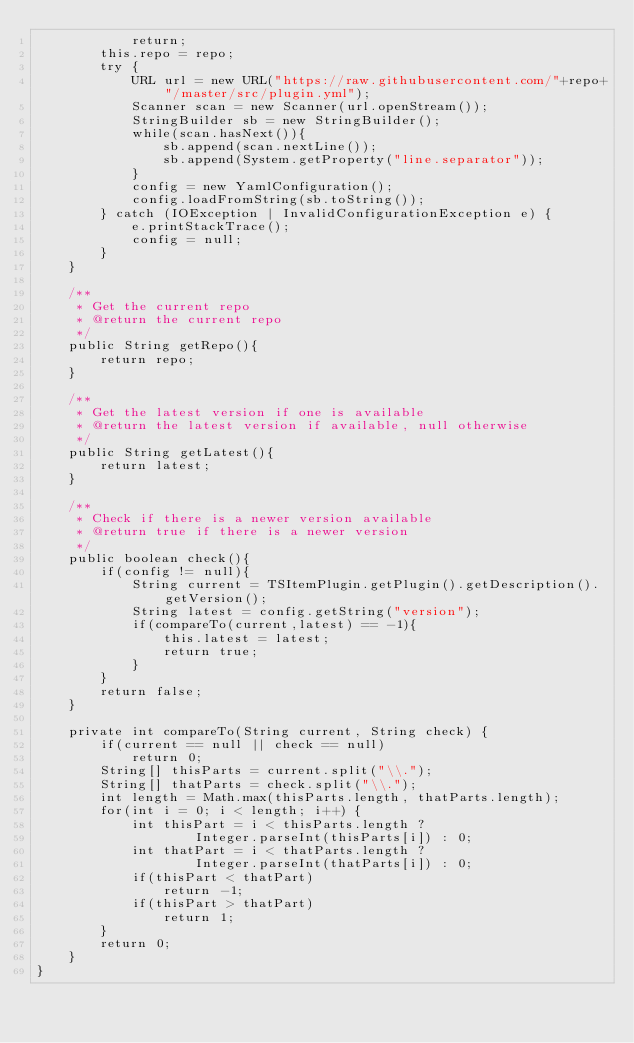Convert code to text. <code><loc_0><loc_0><loc_500><loc_500><_Java_>            return;
        this.repo = repo;
        try {
            URL url = new URL("https://raw.githubusercontent.com/"+repo+"/master/src/plugin.yml");
            Scanner scan = new Scanner(url.openStream());
            StringBuilder sb = new StringBuilder();
            while(scan.hasNext()){
                sb.append(scan.nextLine());
                sb.append(System.getProperty("line.separator"));
            }
            config = new YamlConfiguration();
            config.loadFromString(sb.toString());
        } catch (IOException | InvalidConfigurationException e) {
            e.printStackTrace();
            config = null;
        }
    }

    /**
     * Get the current repo
     * @return the current repo
     */
    public String getRepo(){
        return repo;
    }

    /**
     * Get the latest version if one is available
     * @return the latest version if available, null otherwise
     */
    public String getLatest(){
        return latest;
    }

    /**
     * Check if there is a newer version available
     * @return true if there is a newer version
     */
    public boolean check(){
        if(config != null){
            String current = TSItemPlugin.getPlugin().getDescription().getVersion();
            String latest = config.getString("version");
            if(compareTo(current,latest) == -1){
                this.latest = latest;
                return true;
            }
        }
        return false;
    }

    private int compareTo(String current, String check) {
        if(current == null || check == null)
            return 0;
        String[] thisParts = current.split("\\.");
        String[] thatParts = check.split("\\.");
        int length = Math.max(thisParts.length, thatParts.length);
        for(int i = 0; i < length; i++) {
            int thisPart = i < thisParts.length ?
                    Integer.parseInt(thisParts[i]) : 0;
            int thatPart = i < thatParts.length ?
                    Integer.parseInt(thatParts[i]) : 0;
            if(thisPart < thatPart)
                return -1;
            if(thisPart > thatPart)
                return 1;
        }
        return 0;
    }
}
</code> 